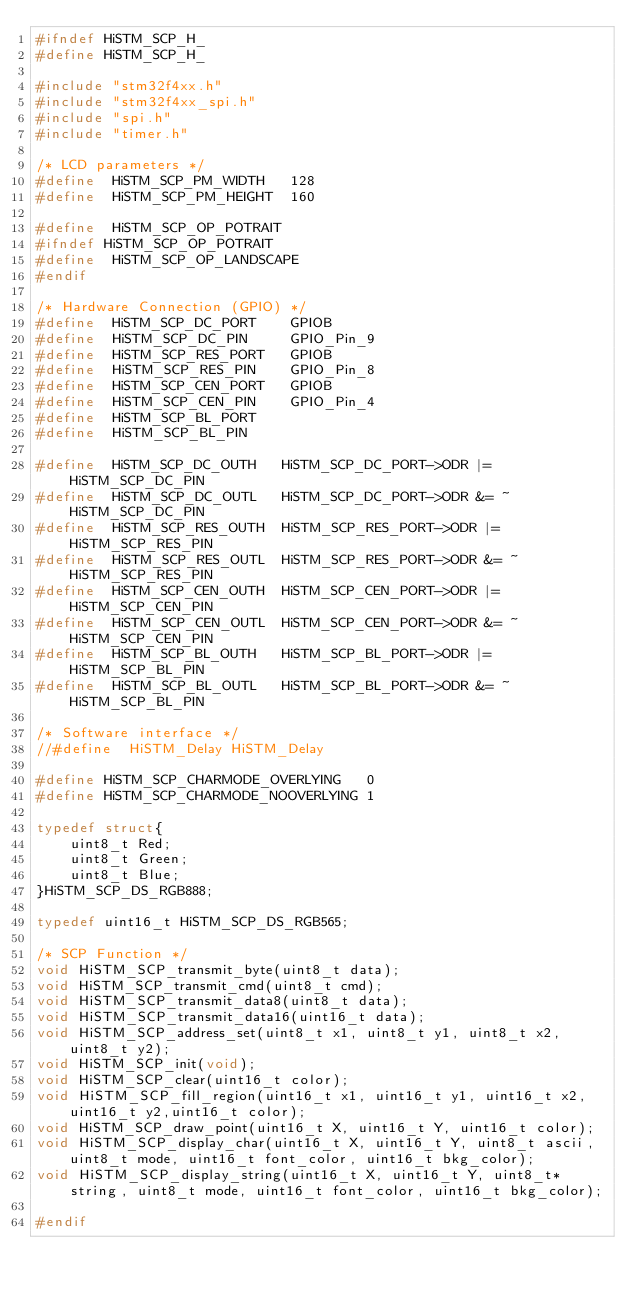<code> <loc_0><loc_0><loc_500><loc_500><_C_>#ifndef HiSTM_SCP_H_
#define HiSTM_SCP_H_

#include "stm32f4xx.h"
#include "stm32f4xx_spi.h"
#include "spi.h"
#include "timer.h"

/* LCD parameters */
#define  HiSTM_SCP_PM_WIDTH   128
#define  HiSTM_SCP_PM_HEIGHT  160

#define  HiSTM_SCP_OP_POTRAIT
#ifndef HiSTM_SCP_OP_POTRAIT
#define  HiSTM_SCP_OP_LANDSCAPE
#endif

/* Hardware Connection (GPIO) */
#define  HiSTM_SCP_DC_PORT    GPIOB
#define  HiSTM_SCP_DC_PIN     GPIO_Pin_9
#define  HiSTM_SCP_RES_PORT   GPIOB
#define  HiSTM_SCP_RES_PIN    GPIO_Pin_8
#define  HiSTM_SCP_CEN_PORT   GPIOB
#define  HiSTM_SCP_CEN_PIN    GPIO_Pin_4
#define  HiSTM_SCP_BL_PORT
#define  HiSTM_SCP_BL_PIN

#define  HiSTM_SCP_DC_OUTH   HiSTM_SCP_DC_PORT->ODR |=  HiSTM_SCP_DC_PIN
#define  HiSTM_SCP_DC_OUTL   HiSTM_SCP_DC_PORT->ODR &= ~HiSTM_SCP_DC_PIN
#define  HiSTM_SCP_RES_OUTH  HiSTM_SCP_RES_PORT->ODR |=  HiSTM_SCP_RES_PIN
#define  HiSTM_SCP_RES_OUTL  HiSTM_SCP_RES_PORT->ODR &= ~HiSTM_SCP_RES_PIN
#define  HiSTM_SCP_CEN_OUTH  HiSTM_SCP_CEN_PORT->ODR |=  HiSTM_SCP_CEN_PIN
#define  HiSTM_SCP_CEN_OUTL  HiSTM_SCP_CEN_PORT->ODR &= ~HiSTM_SCP_CEN_PIN
#define  HiSTM_SCP_BL_OUTH   HiSTM_SCP_BL_PORT->ODR |=  HiSTM_SCP_BL_PIN
#define  HiSTM_SCP_BL_OUTL   HiSTM_SCP_BL_PORT->ODR &= ~HiSTM_SCP_BL_PIN

/* Software interface */
//#define  HiSTM_Delay HiSTM_Delay

#define HiSTM_SCP_CHARMODE_OVERLYING   0
#define HiSTM_SCP_CHARMODE_NOOVERLYING 1

typedef struct{
	uint8_t Red;
	uint8_t Green;
	uint8_t Blue;
}HiSTM_SCP_DS_RGB888;

typedef uint16_t HiSTM_SCP_DS_RGB565;

/* SCP Function */
void HiSTM_SCP_transmit_byte(uint8_t data);
void HiSTM_SCP_transmit_cmd(uint8_t cmd);
void HiSTM_SCP_transmit_data8(uint8_t data);
void HiSTM_SCP_transmit_data16(uint16_t data);
void HiSTM_SCP_address_set(uint8_t x1, uint8_t y1, uint8_t x2, uint8_t y2);
void HiSTM_SCP_init(void);
void HiSTM_SCP_clear(uint16_t color);
void HiSTM_SCP_fill_region(uint16_t x1, uint16_t y1, uint16_t x2, uint16_t y2,uint16_t color);
void HiSTM_SCP_draw_point(uint16_t X, uint16_t Y, uint16_t color);
void HiSTM_SCP_display_char(uint16_t X, uint16_t Y, uint8_t ascii, uint8_t mode, uint16_t font_color, uint16_t bkg_color);
void HiSTM_SCP_display_string(uint16_t X, uint16_t Y, uint8_t* string, uint8_t mode, uint16_t font_color, uint16_t bkg_color);

#endif


</code> 